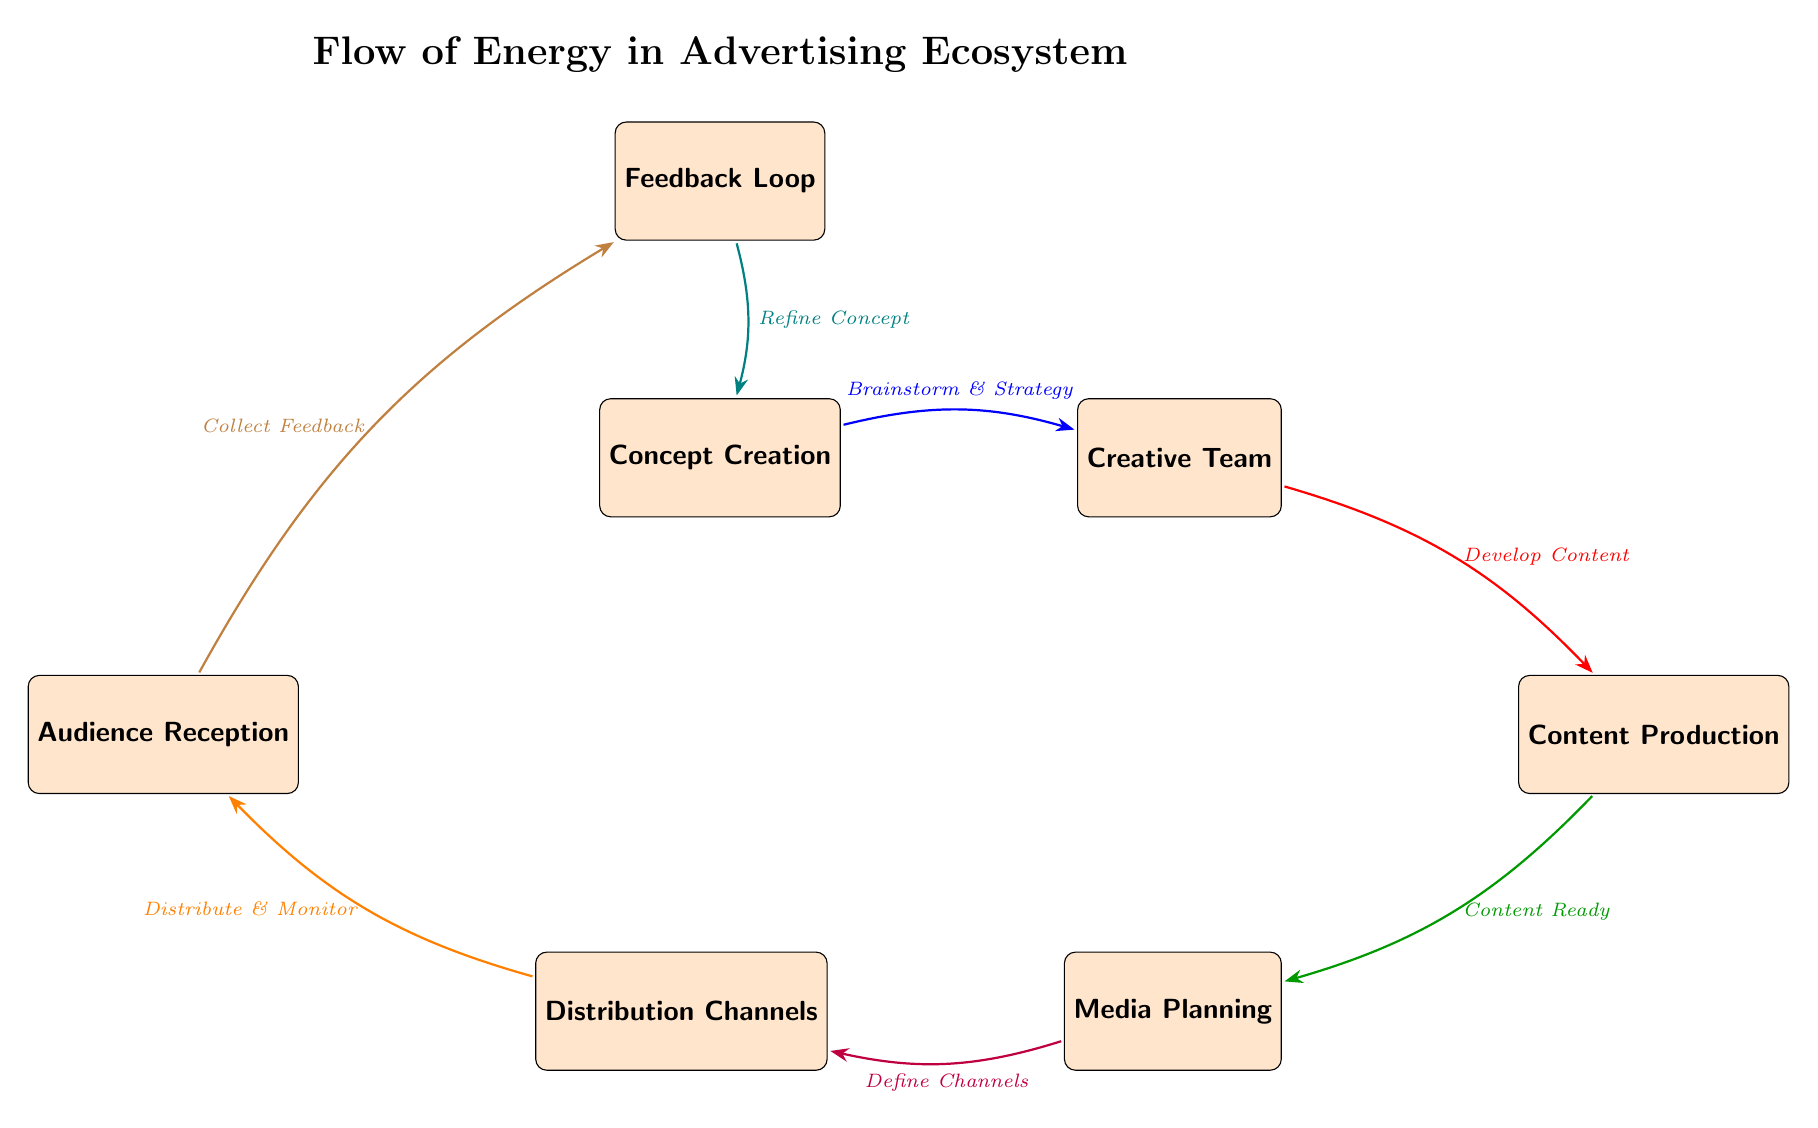What is the first node in the flow? The diagram starts with the node labeled "Concept Creation," which is placed at the top left, indicating the initial stage in the advertising ecosystem.
Answer: Concept Creation How many nodes are present in the diagram? By counting all the distinct boxes in the diagram, we find there are six nodes representing various stages in the advertising process.
Answer: Six What is the process that connects "Creative Team" to "Content Production"? The flow from "Creative Team" to "Content Production" is indicated by the label "Develop Content," which describes the action taken between these two stages.
Answer: Develop Content Which node receives feedback? The node labeled "Audience Reception" is connected to the feedback loop, as it collects feedback which is part of the iterative process represented in the diagram.
Answer: Audience Reception What action is indicated between "Distribution Channels" and "Audience Reception"? The label "Distribute & Monitor" describes the action that occurs from "Distribution Channels" to "Audience Reception," signifying the delivery and observation of content.
Answer: Distribute & Monitor Which two nodes are directly connected by the feedback loop? The "Audience Reception" node and the "Feedback Loop" node are directly connected, indicating a direct line of communication where feedback is collected.
Answer: Audience Reception and Feedback Loop Which node is the last in the flow before feedback? The node "Audience Reception" is the last step in the sequence before reaching the feedback loop, indicating it is a key endpoint for gathering reactions.
Answer: Audience Reception What is the final action represented in the feedback loop? The feedback loop connects back to the initial concept stage with the action "Refine Concept," indicating that feedback informs improvements in conceptualization.
Answer: Refine Concept How does the concept creation process evolve throughout the diagram? The "Concept Creation" generates a structured approach to development, leading through multiple stages: brainstorming, content development, and feedback that cycles back to refinements.
Answer: Iterative Process 